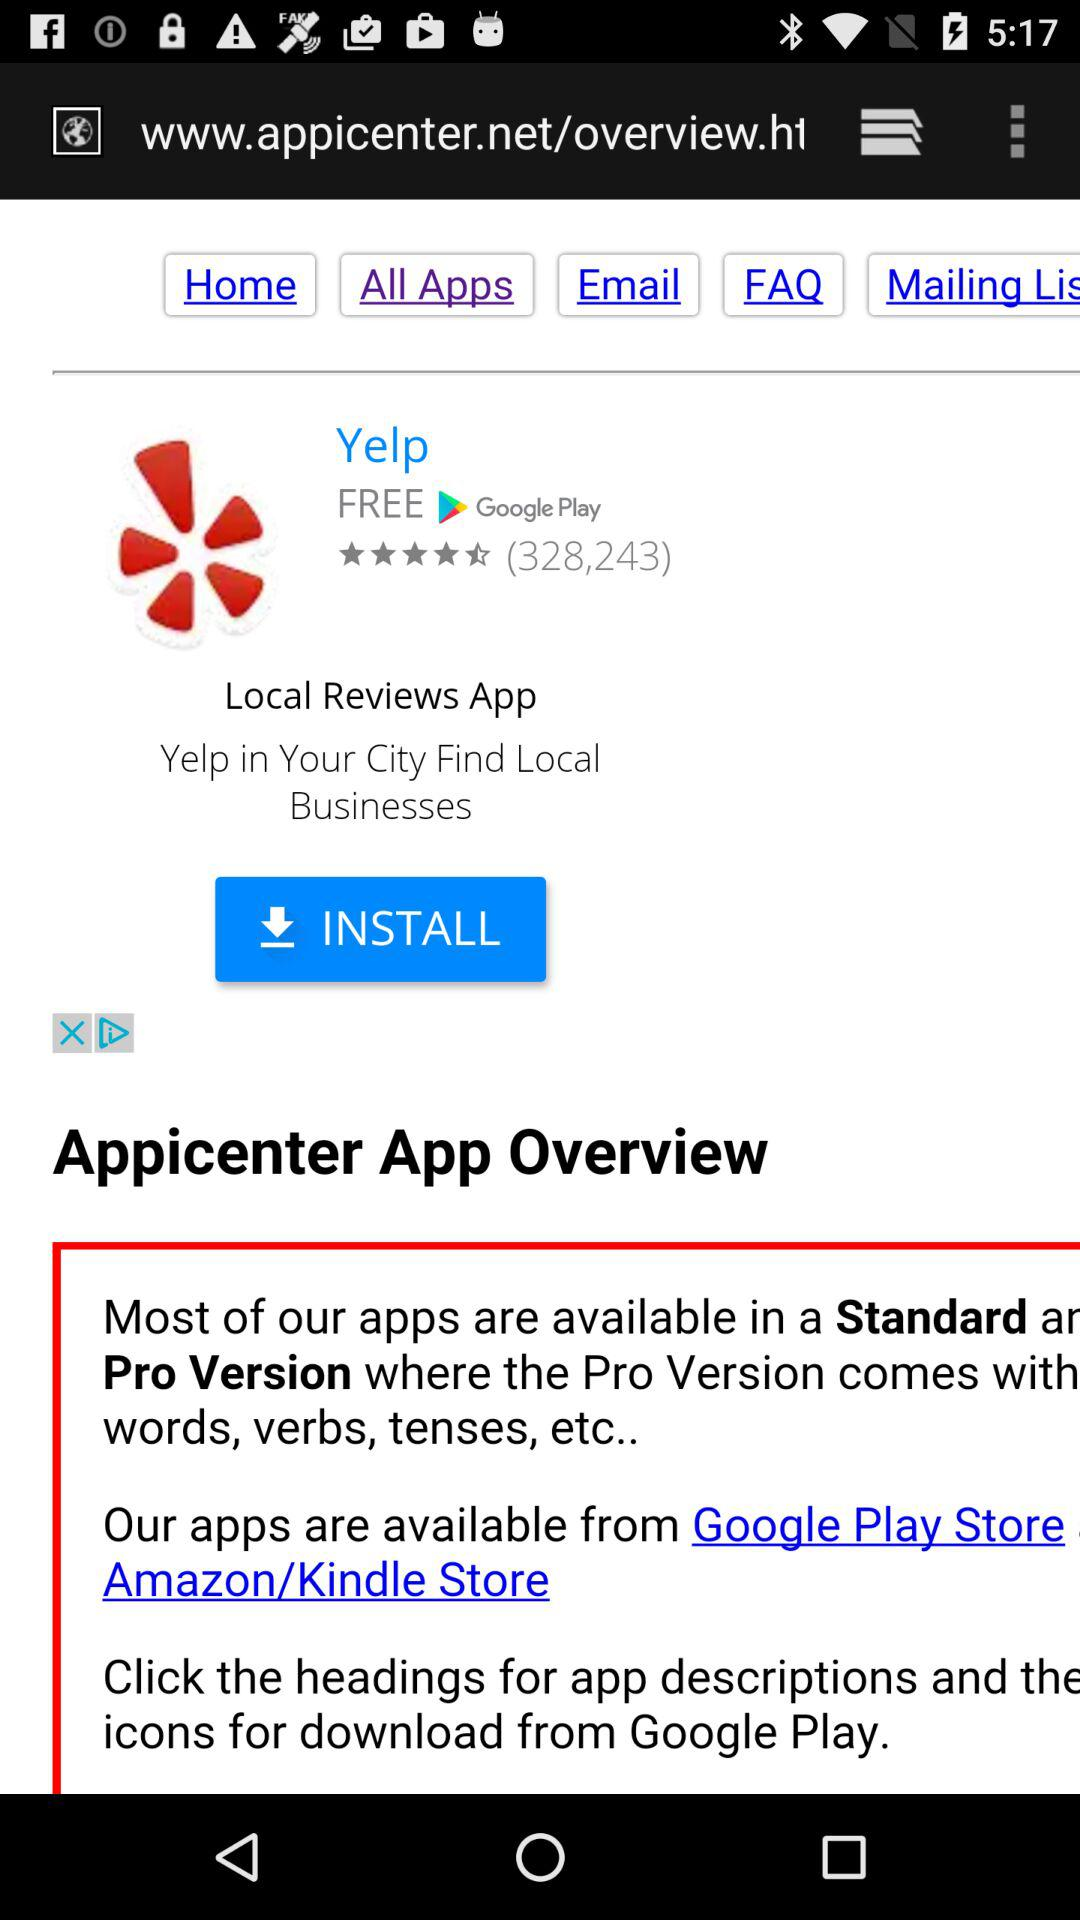What is the name of the application? The name of the application is "Yelp". 